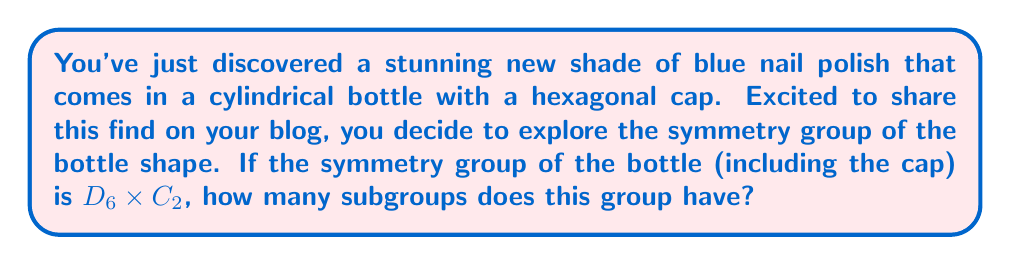Help me with this question. Let's approach this step-by-step:

1) The symmetry group of the bottle is $D_6 \times C_2$, where:
   - $D_6$ is the dihedral group of order 12, representing the symmetries of the hexagonal cap
   - $C_2$ is the cyclic group of order 2, representing the vertical flip symmetry of the cylindrical bottle

2) To find the number of subgroups, we need to use the following theorem:
   If $G = H \times K$, where $H$ and $K$ are groups with coprime orders, then every subgroup of $G$ is of the form $A \times B$, where $A$ is a subgroup of $H$ and $B$ is a subgroup of $K$.

3) In our case, $|D_6| = 12$ and $|C_2| = 2$, which are coprime. So we can apply the theorem.

4) The number of subgroups of $G$ will be the product of the number of subgroups of $D_6$ and the number of subgroups of $C_2$.

5) For $C_2$:
   $C_2$ has 2 subgroups: $\{e\}$ and $C_2$ itself.

6) For $D_6$:
   $D_6$ has 16 subgroups:
   - 1 subgroup of order 12 (D_6 itself)
   - 1 subgroup of order 6 (C_6)
   - 3 subgroups of order 4 (2 V_4 and 1 C_4)
   - 4 subgroups of order 3 (C_3)
   - 3 subgroups of order 2 (reflections)
   - 3 subgroups of order 2 (rotations)
   - 1 trivial subgroup

7) Therefore, the total number of subgroups of $D_6 \times C_2$ is:
   $16 \times 2 = 32$
Answer: The symmetry group $D_6 \times C_2$ of the nail polish bottle has 32 subgroups. 